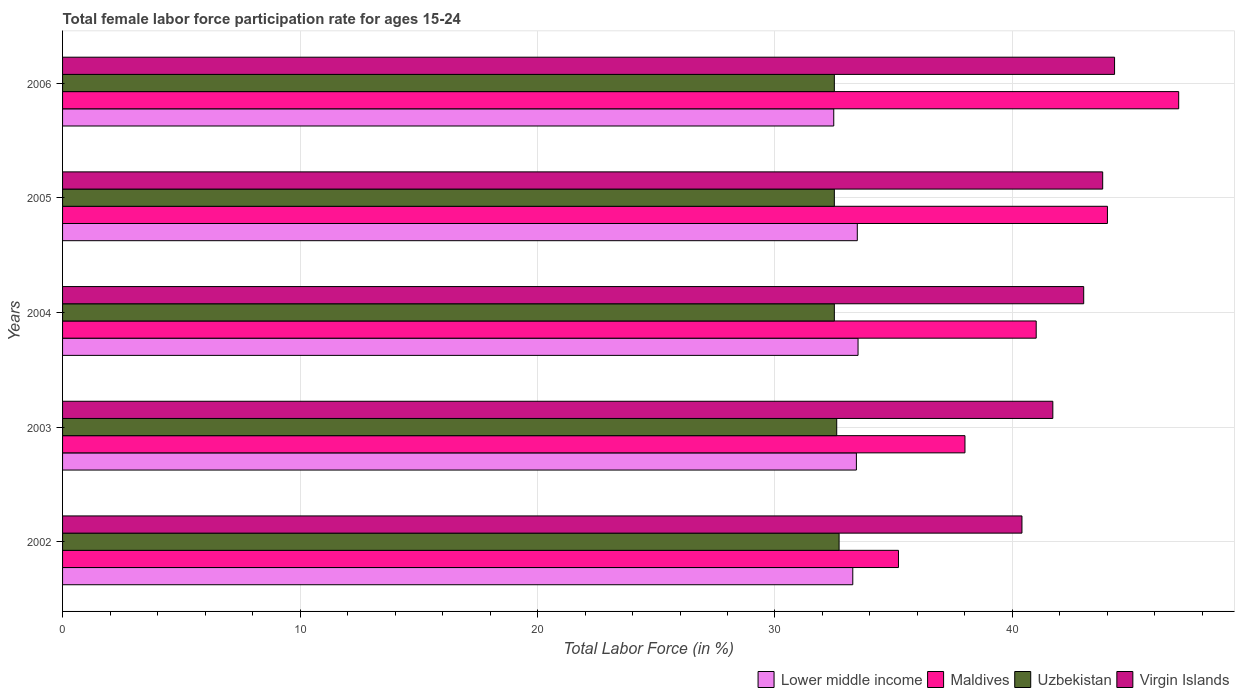How many different coloured bars are there?
Provide a short and direct response. 4. How many groups of bars are there?
Offer a terse response. 5. How many bars are there on the 2nd tick from the bottom?
Your answer should be very brief. 4. What is the label of the 2nd group of bars from the top?
Make the answer very short. 2005. In how many cases, is the number of bars for a given year not equal to the number of legend labels?
Keep it short and to the point. 0. What is the female labor force participation rate in Maldives in 2006?
Provide a short and direct response. 47. Across all years, what is the maximum female labor force participation rate in Virgin Islands?
Make the answer very short. 44.3. Across all years, what is the minimum female labor force participation rate in Virgin Islands?
Your answer should be compact. 40.4. In which year was the female labor force participation rate in Uzbekistan minimum?
Your response must be concise. 2004. What is the total female labor force participation rate in Uzbekistan in the graph?
Make the answer very short. 162.8. What is the difference between the female labor force participation rate in Virgin Islands in 2003 and that in 2005?
Ensure brevity in your answer.  -2.1. What is the difference between the female labor force participation rate in Lower middle income in 2004 and the female labor force participation rate in Uzbekistan in 2003?
Offer a terse response. 0.9. What is the average female labor force participation rate in Lower middle income per year?
Ensure brevity in your answer.  33.23. In the year 2002, what is the difference between the female labor force participation rate in Uzbekistan and female labor force participation rate in Virgin Islands?
Your response must be concise. -7.7. In how many years, is the female labor force participation rate in Lower middle income greater than 32 %?
Your response must be concise. 5. What is the ratio of the female labor force participation rate in Maldives in 2002 to that in 2004?
Offer a terse response. 0.86. Is the difference between the female labor force participation rate in Uzbekistan in 2004 and 2006 greater than the difference between the female labor force participation rate in Virgin Islands in 2004 and 2006?
Your response must be concise. Yes. What is the difference between the highest and the lowest female labor force participation rate in Virgin Islands?
Offer a terse response. 3.9. In how many years, is the female labor force participation rate in Uzbekistan greater than the average female labor force participation rate in Uzbekistan taken over all years?
Your answer should be very brief. 2. Is the sum of the female labor force participation rate in Virgin Islands in 2002 and 2006 greater than the maximum female labor force participation rate in Uzbekistan across all years?
Your answer should be compact. Yes. Is it the case that in every year, the sum of the female labor force participation rate in Virgin Islands and female labor force participation rate in Uzbekistan is greater than the sum of female labor force participation rate in Lower middle income and female labor force participation rate in Maldives?
Offer a terse response. No. What does the 1st bar from the top in 2002 represents?
Your answer should be very brief. Virgin Islands. What does the 2nd bar from the bottom in 2004 represents?
Ensure brevity in your answer.  Maldives. Is it the case that in every year, the sum of the female labor force participation rate in Uzbekistan and female labor force participation rate in Maldives is greater than the female labor force participation rate in Virgin Islands?
Provide a short and direct response. Yes. How many bars are there?
Your response must be concise. 20. Are all the bars in the graph horizontal?
Ensure brevity in your answer.  Yes. How many years are there in the graph?
Make the answer very short. 5. Are the values on the major ticks of X-axis written in scientific E-notation?
Your answer should be very brief. No. Does the graph contain grids?
Ensure brevity in your answer.  Yes. Where does the legend appear in the graph?
Keep it short and to the point. Bottom right. How many legend labels are there?
Provide a succinct answer. 4. How are the legend labels stacked?
Make the answer very short. Horizontal. What is the title of the graph?
Offer a terse response. Total female labor force participation rate for ages 15-24. What is the label or title of the X-axis?
Your answer should be very brief. Total Labor Force (in %). What is the Total Labor Force (in %) in Lower middle income in 2002?
Keep it short and to the point. 33.28. What is the Total Labor Force (in %) in Maldives in 2002?
Your answer should be compact. 35.2. What is the Total Labor Force (in %) of Uzbekistan in 2002?
Your answer should be compact. 32.7. What is the Total Labor Force (in %) in Virgin Islands in 2002?
Make the answer very short. 40.4. What is the Total Labor Force (in %) of Lower middle income in 2003?
Give a very brief answer. 33.43. What is the Total Labor Force (in %) in Uzbekistan in 2003?
Your response must be concise. 32.6. What is the Total Labor Force (in %) in Virgin Islands in 2003?
Your response must be concise. 41.7. What is the Total Labor Force (in %) of Lower middle income in 2004?
Keep it short and to the point. 33.5. What is the Total Labor Force (in %) in Maldives in 2004?
Provide a succinct answer. 41. What is the Total Labor Force (in %) in Uzbekistan in 2004?
Provide a succinct answer. 32.5. What is the Total Labor Force (in %) of Virgin Islands in 2004?
Your response must be concise. 43. What is the Total Labor Force (in %) in Lower middle income in 2005?
Offer a terse response. 33.47. What is the Total Labor Force (in %) of Uzbekistan in 2005?
Keep it short and to the point. 32.5. What is the Total Labor Force (in %) in Virgin Islands in 2005?
Offer a very short reply. 43.8. What is the Total Labor Force (in %) in Lower middle income in 2006?
Give a very brief answer. 32.47. What is the Total Labor Force (in %) in Uzbekistan in 2006?
Ensure brevity in your answer.  32.5. What is the Total Labor Force (in %) of Virgin Islands in 2006?
Provide a succinct answer. 44.3. Across all years, what is the maximum Total Labor Force (in %) in Lower middle income?
Make the answer very short. 33.5. Across all years, what is the maximum Total Labor Force (in %) of Maldives?
Give a very brief answer. 47. Across all years, what is the maximum Total Labor Force (in %) in Uzbekistan?
Offer a terse response. 32.7. Across all years, what is the maximum Total Labor Force (in %) of Virgin Islands?
Keep it short and to the point. 44.3. Across all years, what is the minimum Total Labor Force (in %) of Lower middle income?
Make the answer very short. 32.47. Across all years, what is the minimum Total Labor Force (in %) of Maldives?
Your answer should be very brief. 35.2. Across all years, what is the minimum Total Labor Force (in %) of Uzbekistan?
Make the answer very short. 32.5. Across all years, what is the minimum Total Labor Force (in %) in Virgin Islands?
Your response must be concise. 40.4. What is the total Total Labor Force (in %) in Lower middle income in the graph?
Offer a terse response. 166.14. What is the total Total Labor Force (in %) of Maldives in the graph?
Give a very brief answer. 205.2. What is the total Total Labor Force (in %) in Uzbekistan in the graph?
Keep it short and to the point. 162.8. What is the total Total Labor Force (in %) of Virgin Islands in the graph?
Offer a terse response. 213.2. What is the difference between the Total Labor Force (in %) of Lower middle income in 2002 and that in 2003?
Give a very brief answer. -0.15. What is the difference between the Total Labor Force (in %) of Maldives in 2002 and that in 2003?
Your response must be concise. -2.8. What is the difference between the Total Labor Force (in %) of Uzbekistan in 2002 and that in 2003?
Provide a short and direct response. 0.1. What is the difference between the Total Labor Force (in %) in Lower middle income in 2002 and that in 2004?
Ensure brevity in your answer.  -0.22. What is the difference between the Total Labor Force (in %) in Maldives in 2002 and that in 2004?
Make the answer very short. -5.8. What is the difference between the Total Labor Force (in %) of Uzbekistan in 2002 and that in 2004?
Give a very brief answer. 0.2. What is the difference between the Total Labor Force (in %) in Lower middle income in 2002 and that in 2005?
Keep it short and to the point. -0.19. What is the difference between the Total Labor Force (in %) of Maldives in 2002 and that in 2005?
Provide a succinct answer. -8.8. What is the difference between the Total Labor Force (in %) of Virgin Islands in 2002 and that in 2005?
Keep it short and to the point. -3.4. What is the difference between the Total Labor Force (in %) in Lower middle income in 2002 and that in 2006?
Your answer should be very brief. 0.8. What is the difference between the Total Labor Force (in %) of Uzbekistan in 2002 and that in 2006?
Your answer should be very brief. 0.2. What is the difference between the Total Labor Force (in %) of Lower middle income in 2003 and that in 2004?
Your response must be concise. -0.07. What is the difference between the Total Labor Force (in %) of Uzbekistan in 2003 and that in 2004?
Provide a short and direct response. 0.1. What is the difference between the Total Labor Force (in %) of Lower middle income in 2003 and that in 2005?
Provide a short and direct response. -0.04. What is the difference between the Total Labor Force (in %) in Maldives in 2003 and that in 2005?
Your answer should be compact. -6. What is the difference between the Total Labor Force (in %) of Uzbekistan in 2003 and that in 2005?
Give a very brief answer. 0.1. What is the difference between the Total Labor Force (in %) of Lower middle income in 2003 and that in 2006?
Provide a succinct answer. 0.95. What is the difference between the Total Labor Force (in %) in Maldives in 2003 and that in 2006?
Ensure brevity in your answer.  -9. What is the difference between the Total Labor Force (in %) in Virgin Islands in 2003 and that in 2006?
Your answer should be compact. -2.6. What is the difference between the Total Labor Force (in %) in Lower middle income in 2004 and that in 2005?
Ensure brevity in your answer.  0.03. What is the difference between the Total Labor Force (in %) in Uzbekistan in 2004 and that in 2005?
Offer a very short reply. 0. What is the difference between the Total Labor Force (in %) in Virgin Islands in 2004 and that in 2005?
Offer a terse response. -0.8. What is the difference between the Total Labor Force (in %) of Lower middle income in 2004 and that in 2006?
Make the answer very short. 1.02. What is the difference between the Total Labor Force (in %) in Maldives in 2004 and that in 2006?
Offer a very short reply. -6. What is the difference between the Total Labor Force (in %) of Uzbekistan in 2004 and that in 2006?
Ensure brevity in your answer.  0. What is the difference between the Total Labor Force (in %) of Lower middle income in 2005 and that in 2006?
Offer a very short reply. 0.99. What is the difference between the Total Labor Force (in %) in Maldives in 2005 and that in 2006?
Give a very brief answer. -3. What is the difference between the Total Labor Force (in %) of Uzbekistan in 2005 and that in 2006?
Offer a terse response. 0. What is the difference between the Total Labor Force (in %) of Virgin Islands in 2005 and that in 2006?
Your answer should be compact. -0.5. What is the difference between the Total Labor Force (in %) in Lower middle income in 2002 and the Total Labor Force (in %) in Maldives in 2003?
Offer a terse response. -4.72. What is the difference between the Total Labor Force (in %) in Lower middle income in 2002 and the Total Labor Force (in %) in Uzbekistan in 2003?
Ensure brevity in your answer.  0.68. What is the difference between the Total Labor Force (in %) in Lower middle income in 2002 and the Total Labor Force (in %) in Virgin Islands in 2003?
Give a very brief answer. -8.42. What is the difference between the Total Labor Force (in %) of Maldives in 2002 and the Total Labor Force (in %) of Uzbekistan in 2003?
Your answer should be very brief. 2.6. What is the difference between the Total Labor Force (in %) in Uzbekistan in 2002 and the Total Labor Force (in %) in Virgin Islands in 2003?
Make the answer very short. -9. What is the difference between the Total Labor Force (in %) in Lower middle income in 2002 and the Total Labor Force (in %) in Maldives in 2004?
Keep it short and to the point. -7.72. What is the difference between the Total Labor Force (in %) of Lower middle income in 2002 and the Total Labor Force (in %) of Uzbekistan in 2004?
Offer a very short reply. 0.78. What is the difference between the Total Labor Force (in %) in Lower middle income in 2002 and the Total Labor Force (in %) in Virgin Islands in 2004?
Your answer should be compact. -9.72. What is the difference between the Total Labor Force (in %) of Maldives in 2002 and the Total Labor Force (in %) of Virgin Islands in 2004?
Offer a terse response. -7.8. What is the difference between the Total Labor Force (in %) of Lower middle income in 2002 and the Total Labor Force (in %) of Maldives in 2005?
Your answer should be compact. -10.72. What is the difference between the Total Labor Force (in %) in Lower middle income in 2002 and the Total Labor Force (in %) in Uzbekistan in 2005?
Offer a very short reply. 0.78. What is the difference between the Total Labor Force (in %) in Lower middle income in 2002 and the Total Labor Force (in %) in Virgin Islands in 2005?
Your response must be concise. -10.52. What is the difference between the Total Labor Force (in %) in Maldives in 2002 and the Total Labor Force (in %) in Uzbekistan in 2005?
Provide a short and direct response. 2.7. What is the difference between the Total Labor Force (in %) of Maldives in 2002 and the Total Labor Force (in %) of Virgin Islands in 2005?
Provide a short and direct response. -8.6. What is the difference between the Total Labor Force (in %) of Lower middle income in 2002 and the Total Labor Force (in %) of Maldives in 2006?
Give a very brief answer. -13.72. What is the difference between the Total Labor Force (in %) in Lower middle income in 2002 and the Total Labor Force (in %) in Uzbekistan in 2006?
Provide a succinct answer. 0.78. What is the difference between the Total Labor Force (in %) in Lower middle income in 2002 and the Total Labor Force (in %) in Virgin Islands in 2006?
Make the answer very short. -11.02. What is the difference between the Total Labor Force (in %) in Maldives in 2002 and the Total Labor Force (in %) in Uzbekistan in 2006?
Ensure brevity in your answer.  2.7. What is the difference between the Total Labor Force (in %) in Maldives in 2002 and the Total Labor Force (in %) in Virgin Islands in 2006?
Offer a terse response. -9.1. What is the difference between the Total Labor Force (in %) of Uzbekistan in 2002 and the Total Labor Force (in %) of Virgin Islands in 2006?
Your response must be concise. -11.6. What is the difference between the Total Labor Force (in %) of Lower middle income in 2003 and the Total Labor Force (in %) of Maldives in 2004?
Your response must be concise. -7.57. What is the difference between the Total Labor Force (in %) of Lower middle income in 2003 and the Total Labor Force (in %) of Uzbekistan in 2004?
Make the answer very short. 0.93. What is the difference between the Total Labor Force (in %) of Lower middle income in 2003 and the Total Labor Force (in %) of Virgin Islands in 2004?
Your answer should be compact. -9.57. What is the difference between the Total Labor Force (in %) in Maldives in 2003 and the Total Labor Force (in %) in Uzbekistan in 2004?
Make the answer very short. 5.5. What is the difference between the Total Labor Force (in %) in Uzbekistan in 2003 and the Total Labor Force (in %) in Virgin Islands in 2004?
Your response must be concise. -10.4. What is the difference between the Total Labor Force (in %) in Lower middle income in 2003 and the Total Labor Force (in %) in Maldives in 2005?
Keep it short and to the point. -10.57. What is the difference between the Total Labor Force (in %) of Lower middle income in 2003 and the Total Labor Force (in %) of Uzbekistan in 2005?
Provide a short and direct response. 0.93. What is the difference between the Total Labor Force (in %) of Lower middle income in 2003 and the Total Labor Force (in %) of Virgin Islands in 2005?
Offer a terse response. -10.37. What is the difference between the Total Labor Force (in %) in Uzbekistan in 2003 and the Total Labor Force (in %) in Virgin Islands in 2005?
Keep it short and to the point. -11.2. What is the difference between the Total Labor Force (in %) in Lower middle income in 2003 and the Total Labor Force (in %) in Maldives in 2006?
Give a very brief answer. -13.57. What is the difference between the Total Labor Force (in %) in Lower middle income in 2003 and the Total Labor Force (in %) in Uzbekistan in 2006?
Offer a very short reply. 0.93. What is the difference between the Total Labor Force (in %) of Lower middle income in 2003 and the Total Labor Force (in %) of Virgin Islands in 2006?
Your response must be concise. -10.87. What is the difference between the Total Labor Force (in %) of Maldives in 2003 and the Total Labor Force (in %) of Uzbekistan in 2006?
Provide a short and direct response. 5.5. What is the difference between the Total Labor Force (in %) in Lower middle income in 2004 and the Total Labor Force (in %) in Maldives in 2005?
Keep it short and to the point. -10.5. What is the difference between the Total Labor Force (in %) in Lower middle income in 2004 and the Total Labor Force (in %) in Virgin Islands in 2005?
Provide a succinct answer. -10.3. What is the difference between the Total Labor Force (in %) in Maldives in 2004 and the Total Labor Force (in %) in Virgin Islands in 2005?
Provide a short and direct response. -2.8. What is the difference between the Total Labor Force (in %) of Lower middle income in 2004 and the Total Labor Force (in %) of Maldives in 2006?
Your answer should be compact. -13.5. What is the difference between the Total Labor Force (in %) in Lower middle income in 2004 and the Total Labor Force (in %) in Virgin Islands in 2006?
Make the answer very short. -10.8. What is the difference between the Total Labor Force (in %) of Maldives in 2004 and the Total Labor Force (in %) of Uzbekistan in 2006?
Provide a short and direct response. 8.5. What is the difference between the Total Labor Force (in %) of Uzbekistan in 2004 and the Total Labor Force (in %) of Virgin Islands in 2006?
Your response must be concise. -11.8. What is the difference between the Total Labor Force (in %) of Lower middle income in 2005 and the Total Labor Force (in %) of Maldives in 2006?
Offer a very short reply. -13.53. What is the difference between the Total Labor Force (in %) in Lower middle income in 2005 and the Total Labor Force (in %) in Uzbekistan in 2006?
Your answer should be compact. 0.97. What is the difference between the Total Labor Force (in %) of Lower middle income in 2005 and the Total Labor Force (in %) of Virgin Islands in 2006?
Your answer should be very brief. -10.83. What is the difference between the Total Labor Force (in %) in Maldives in 2005 and the Total Labor Force (in %) in Uzbekistan in 2006?
Offer a terse response. 11.5. What is the difference between the Total Labor Force (in %) of Maldives in 2005 and the Total Labor Force (in %) of Virgin Islands in 2006?
Make the answer very short. -0.3. What is the difference between the Total Labor Force (in %) of Uzbekistan in 2005 and the Total Labor Force (in %) of Virgin Islands in 2006?
Offer a terse response. -11.8. What is the average Total Labor Force (in %) in Lower middle income per year?
Make the answer very short. 33.23. What is the average Total Labor Force (in %) in Maldives per year?
Your answer should be very brief. 41.04. What is the average Total Labor Force (in %) in Uzbekistan per year?
Ensure brevity in your answer.  32.56. What is the average Total Labor Force (in %) of Virgin Islands per year?
Your response must be concise. 42.64. In the year 2002, what is the difference between the Total Labor Force (in %) of Lower middle income and Total Labor Force (in %) of Maldives?
Your response must be concise. -1.92. In the year 2002, what is the difference between the Total Labor Force (in %) of Lower middle income and Total Labor Force (in %) of Uzbekistan?
Offer a very short reply. 0.58. In the year 2002, what is the difference between the Total Labor Force (in %) of Lower middle income and Total Labor Force (in %) of Virgin Islands?
Offer a terse response. -7.12. In the year 2002, what is the difference between the Total Labor Force (in %) in Maldives and Total Labor Force (in %) in Uzbekistan?
Make the answer very short. 2.5. In the year 2002, what is the difference between the Total Labor Force (in %) of Maldives and Total Labor Force (in %) of Virgin Islands?
Keep it short and to the point. -5.2. In the year 2003, what is the difference between the Total Labor Force (in %) of Lower middle income and Total Labor Force (in %) of Maldives?
Your answer should be compact. -4.57. In the year 2003, what is the difference between the Total Labor Force (in %) of Lower middle income and Total Labor Force (in %) of Uzbekistan?
Provide a succinct answer. 0.83. In the year 2003, what is the difference between the Total Labor Force (in %) in Lower middle income and Total Labor Force (in %) in Virgin Islands?
Your response must be concise. -8.27. In the year 2003, what is the difference between the Total Labor Force (in %) of Uzbekistan and Total Labor Force (in %) of Virgin Islands?
Provide a succinct answer. -9.1. In the year 2004, what is the difference between the Total Labor Force (in %) of Lower middle income and Total Labor Force (in %) of Maldives?
Ensure brevity in your answer.  -7.5. In the year 2004, what is the difference between the Total Labor Force (in %) of Lower middle income and Total Labor Force (in %) of Uzbekistan?
Your answer should be very brief. 1. In the year 2004, what is the difference between the Total Labor Force (in %) of Lower middle income and Total Labor Force (in %) of Virgin Islands?
Your answer should be compact. -9.5. In the year 2004, what is the difference between the Total Labor Force (in %) of Uzbekistan and Total Labor Force (in %) of Virgin Islands?
Offer a very short reply. -10.5. In the year 2005, what is the difference between the Total Labor Force (in %) of Lower middle income and Total Labor Force (in %) of Maldives?
Keep it short and to the point. -10.53. In the year 2005, what is the difference between the Total Labor Force (in %) in Lower middle income and Total Labor Force (in %) in Uzbekistan?
Keep it short and to the point. 0.97. In the year 2005, what is the difference between the Total Labor Force (in %) in Lower middle income and Total Labor Force (in %) in Virgin Islands?
Make the answer very short. -10.33. In the year 2005, what is the difference between the Total Labor Force (in %) in Maldives and Total Labor Force (in %) in Uzbekistan?
Provide a short and direct response. 11.5. In the year 2005, what is the difference between the Total Labor Force (in %) of Maldives and Total Labor Force (in %) of Virgin Islands?
Keep it short and to the point. 0.2. In the year 2005, what is the difference between the Total Labor Force (in %) in Uzbekistan and Total Labor Force (in %) in Virgin Islands?
Keep it short and to the point. -11.3. In the year 2006, what is the difference between the Total Labor Force (in %) of Lower middle income and Total Labor Force (in %) of Maldives?
Keep it short and to the point. -14.53. In the year 2006, what is the difference between the Total Labor Force (in %) of Lower middle income and Total Labor Force (in %) of Uzbekistan?
Your response must be concise. -0.03. In the year 2006, what is the difference between the Total Labor Force (in %) in Lower middle income and Total Labor Force (in %) in Virgin Islands?
Give a very brief answer. -11.83. In the year 2006, what is the difference between the Total Labor Force (in %) of Maldives and Total Labor Force (in %) of Uzbekistan?
Keep it short and to the point. 14.5. In the year 2006, what is the difference between the Total Labor Force (in %) of Maldives and Total Labor Force (in %) of Virgin Islands?
Offer a terse response. 2.7. In the year 2006, what is the difference between the Total Labor Force (in %) of Uzbekistan and Total Labor Force (in %) of Virgin Islands?
Keep it short and to the point. -11.8. What is the ratio of the Total Labor Force (in %) of Maldives in 2002 to that in 2003?
Keep it short and to the point. 0.93. What is the ratio of the Total Labor Force (in %) of Uzbekistan in 2002 to that in 2003?
Provide a short and direct response. 1. What is the ratio of the Total Labor Force (in %) of Virgin Islands in 2002 to that in 2003?
Your answer should be very brief. 0.97. What is the ratio of the Total Labor Force (in %) of Lower middle income in 2002 to that in 2004?
Keep it short and to the point. 0.99. What is the ratio of the Total Labor Force (in %) of Maldives in 2002 to that in 2004?
Your answer should be very brief. 0.86. What is the ratio of the Total Labor Force (in %) in Uzbekistan in 2002 to that in 2004?
Make the answer very short. 1.01. What is the ratio of the Total Labor Force (in %) in Virgin Islands in 2002 to that in 2004?
Provide a short and direct response. 0.94. What is the ratio of the Total Labor Force (in %) of Lower middle income in 2002 to that in 2005?
Provide a short and direct response. 0.99. What is the ratio of the Total Labor Force (in %) of Maldives in 2002 to that in 2005?
Give a very brief answer. 0.8. What is the ratio of the Total Labor Force (in %) in Uzbekistan in 2002 to that in 2005?
Make the answer very short. 1.01. What is the ratio of the Total Labor Force (in %) in Virgin Islands in 2002 to that in 2005?
Provide a succinct answer. 0.92. What is the ratio of the Total Labor Force (in %) in Lower middle income in 2002 to that in 2006?
Your answer should be compact. 1.02. What is the ratio of the Total Labor Force (in %) of Maldives in 2002 to that in 2006?
Provide a succinct answer. 0.75. What is the ratio of the Total Labor Force (in %) of Virgin Islands in 2002 to that in 2006?
Provide a short and direct response. 0.91. What is the ratio of the Total Labor Force (in %) in Lower middle income in 2003 to that in 2004?
Offer a terse response. 1. What is the ratio of the Total Labor Force (in %) in Maldives in 2003 to that in 2004?
Your answer should be compact. 0.93. What is the ratio of the Total Labor Force (in %) in Uzbekistan in 2003 to that in 2004?
Ensure brevity in your answer.  1. What is the ratio of the Total Labor Force (in %) of Virgin Islands in 2003 to that in 2004?
Ensure brevity in your answer.  0.97. What is the ratio of the Total Labor Force (in %) in Maldives in 2003 to that in 2005?
Your answer should be compact. 0.86. What is the ratio of the Total Labor Force (in %) of Uzbekistan in 2003 to that in 2005?
Provide a succinct answer. 1. What is the ratio of the Total Labor Force (in %) of Virgin Islands in 2003 to that in 2005?
Offer a terse response. 0.95. What is the ratio of the Total Labor Force (in %) of Lower middle income in 2003 to that in 2006?
Provide a succinct answer. 1.03. What is the ratio of the Total Labor Force (in %) in Maldives in 2003 to that in 2006?
Your response must be concise. 0.81. What is the ratio of the Total Labor Force (in %) of Uzbekistan in 2003 to that in 2006?
Provide a short and direct response. 1. What is the ratio of the Total Labor Force (in %) of Virgin Islands in 2003 to that in 2006?
Keep it short and to the point. 0.94. What is the ratio of the Total Labor Force (in %) of Lower middle income in 2004 to that in 2005?
Your response must be concise. 1. What is the ratio of the Total Labor Force (in %) of Maldives in 2004 to that in 2005?
Ensure brevity in your answer.  0.93. What is the ratio of the Total Labor Force (in %) in Virgin Islands in 2004 to that in 2005?
Ensure brevity in your answer.  0.98. What is the ratio of the Total Labor Force (in %) of Lower middle income in 2004 to that in 2006?
Provide a short and direct response. 1.03. What is the ratio of the Total Labor Force (in %) of Maldives in 2004 to that in 2006?
Your answer should be compact. 0.87. What is the ratio of the Total Labor Force (in %) of Uzbekistan in 2004 to that in 2006?
Offer a very short reply. 1. What is the ratio of the Total Labor Force (in %) of Virgin Islands in 2004 to that in 2006?
Your answer should be compact. 0.97. What is the ratio of the Total Labor Force (in %) in Lower middle income in 2005 to that in 2006?
Ensure brevity in your answer.  1.03. What is the ratio of the Total Labor Force (in %) of Maldives in 2005 to that in 2006?
Provide a short and direct response. 0.94. What is the ratio of the Total Labor Force (in %) of Uzbekistan in 2005 to that in 2006?
Ensure brevity in your answer.  1. What is the ratio of the Total Labor Force (in %) of Virgin Islands in 2005 to that in 2006?
Offer a terse response. 0.99. What is the difference between the highest and the second highest Total Labor Force (in %) in Lower middle income?
Provide a short and direct response. 0.03. What is the difference between the highest and the second highest Total Labor Force (in %) in Uzbekistan?
Provide a short and direct response. 0.1. What is the difference between the highest and the lowest Total Labor Force (in %) of Lower middle income?
Offer a terse response. 1.02. What is the difference between the highest and the lowest Total Labor Force (in %) of Maldives?
Your answer should be compact. 11.8. What is the difference between the highest and the lowest Total Labor Force (in %) in Uzbekistan?
Offer a terse response. 0.2. 